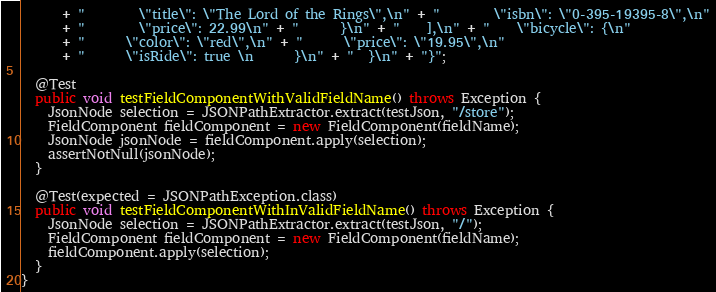Convert code to text. <code><loc_0><loc_0><loc_500><loc_500><_Java_>      + "        \"title\": \"The Lord of the Rings\",\n" + "        \"isbn\": \"0-395-19395-8\",\n"
      + "        \"price\": 22.99\n" + "      }\n" + "    ],\n" + "    \"bicycle\": {\n"
      + "      \"color\": \"red\",\n" + "      \"price\": \"19.95\",\n"
      + "      \"isRide\": true \n      }\n" + "  }\n" + "}";

  @Test
  public void testFieldComponentWithValidFieldName() throws Exception {
    JsonNode selection = JSONPathExtractor.extract(testJson, "/store");
    FieldComponent fieldComponent = new FieldComponent(fieldName);
    JsonNode jsonNode = fieldComponent.apply(selection);
    assertNotNull(jsonNode);
  }

  @Test(expected = JSONPathException.class)
  public void testFieldComponentWithInValidFieldName() throws Exception {
    JsonNode selection = JSONPathExtractor.extract(testJson, "/");
    FieldComponent fieldComponent = new FieldComponent(fieldName);
    fieldComponent.apply(selection);
  }
}
</code> 